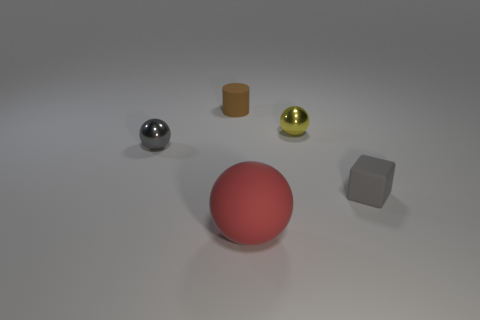Subtract all yellow spheres. How many spheres are left? 2 Subtract all cylinders. How many objects are left? 4 Subtract 1 spheres. How many spheres are left? 2 Add 1 yellow metallic balls. How many objects exist? 6 Subtract all big brown rubber balls. Subtract all red rubber objects. How many objects are left? 4 Add 5 gray spheres. How many gray spheres are left? 6 Add 3 small green rubber blocks. How many small green rubber blocks exist? 3 Subtract all gray spheres. How many spheres are left? 2 Subtract 0 yellow cubes. How many objects are left? 5 Subtract all yellow cylinders. Subtract all purple spheres. How many cylinders are left? 1 